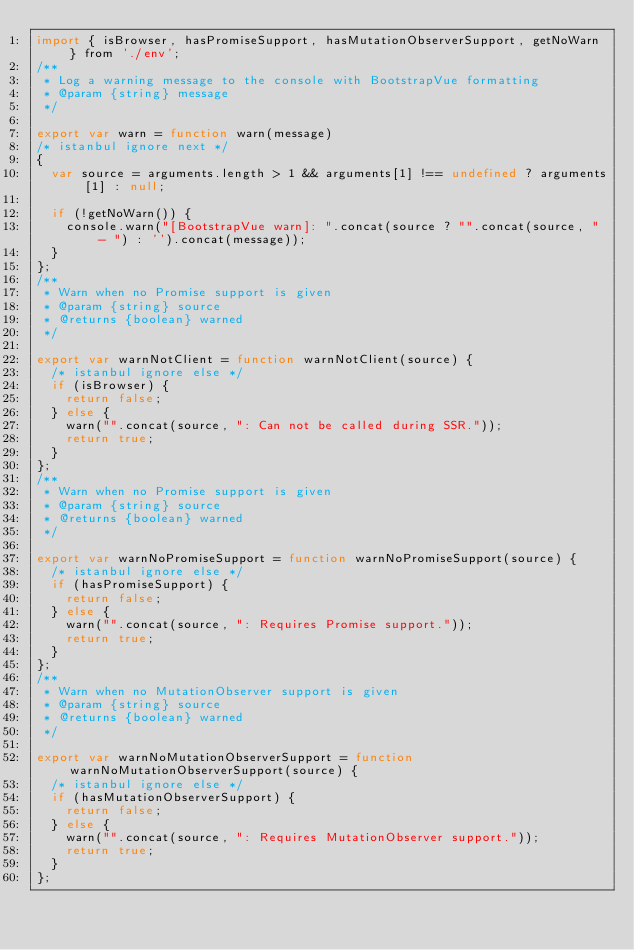Convert code to text. <code><loc_0><loc_0><loc_500><loc_500><_JavaScript_>import { isBrowser, hasPromiseSupport, hasMutationObserverSupport, getNoWarn } from './env';
/**
 * Log a warning message to the console with BootstrapVue formatting
 * @param {string} message
 */

export var warn = function warn(message)
/* istanbul ignore next */
{
  var source = arguments.length > 1 && arguments[1] !== undefined ? arguments[1] : null;

  if (!getNoWarn()) {
    console.warn("[BootstrapVue warn]: ".concat(source ? "".concat(source, " - ") : '').concat(message));
  }
};
/**
 * Warn when no Promise support is given
 * @param {string} source
 * @returns {boolean} warned
 */

export var warnNotClient = function warnNotClient(source) {
  /* istanbul ignore else */
  if (isBrowser) {
    return false;
  } else {
    warn("".concat(source, ": Can not be called during SSR."));
    return true;
  }
};
/**
 * Warn when no Promise support is given
 * @param {string} source
 * @returns {boolean} warned
 */

export var warnNoPromiseSupport = function warnNoPromiseSupport(source) {
  /* istanbul ignore else */
  if (hasPromiseSupport) {
    return false;
  } else {
    warn("".concat(source, ": Requires Promise support."));
    return true;
  }
};
/**
 * Warn when no MutationObserver support is given
 * @param {string} source
 * @returns {boolean} warned
 */

export var warnNoMutationObserverSupport = function warnNoMutationObserverSupport(source) {
  /* istanbul ignore else */
  if (hasMutationObserverSupport) {
    return false;
  } else {
    warn("".concat(source, ": Requires MutationObserver support."));
    return true;
  }
};</code> 